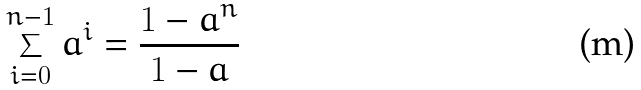Convert formula to latex. <formula><loc_0><loc_0><loc_500><loc_500>\sum _ { i = 0 } ^ { n - 1 } a ^ { i } = { \frac { 1 - a ^ { n } } { 1 - a } }</formula> 